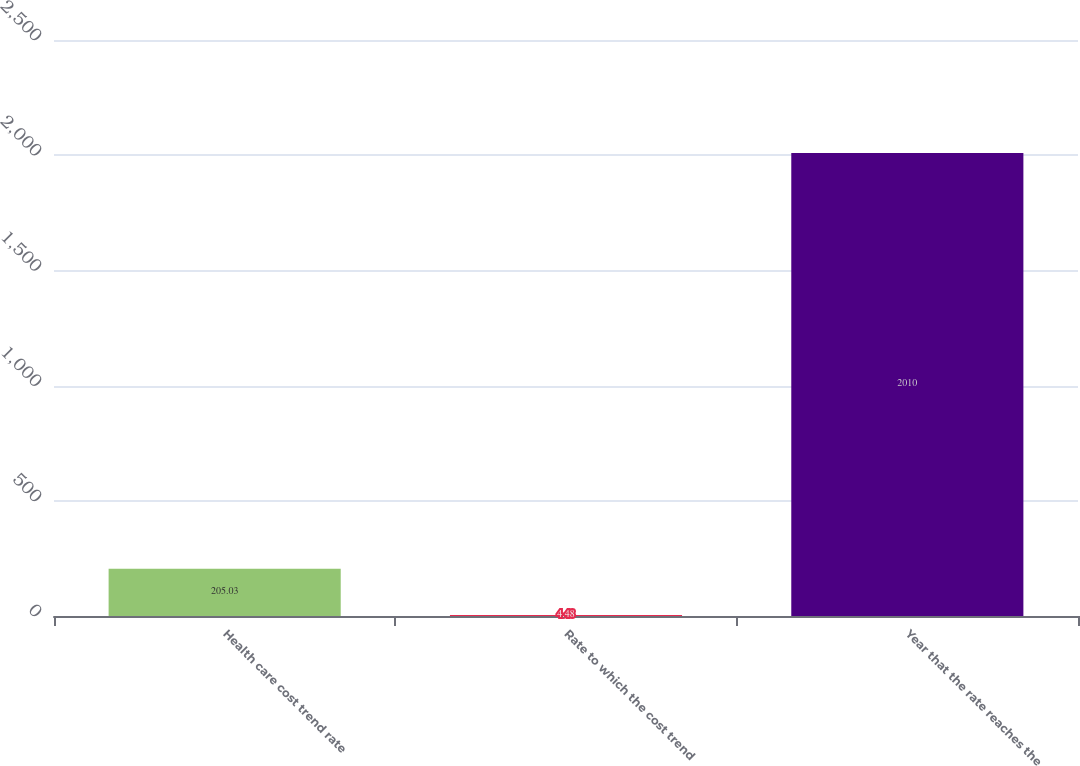Convert chart to OTSL. <chart><loc_0><loc_0><loc_500><loc_500><bar_chart><fcel>Health care cost trend rate<fcel>Rate to which the cost trend<fcel>Year that the rate reaches the<nl><fcel>205.03<fcel>4.48<fcel>2010<nl></chart> 